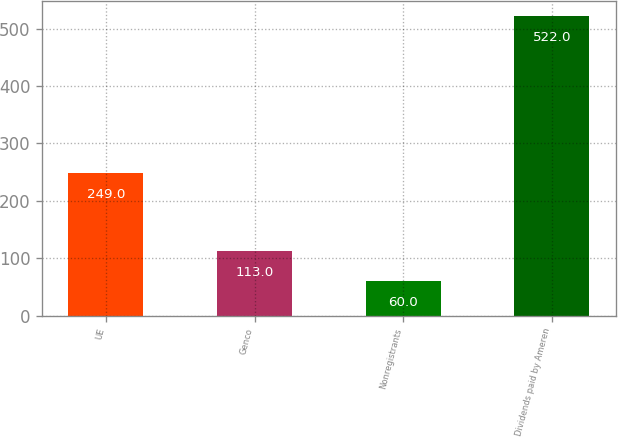Convert chart. <chart><loc_0><loc_0><loc_500><loc_500><bar_chart><fcel>UE<fcel>Genco<fcel>Nonregistrants<fcel>Dividends paid by Ameren<nl><fcel>249<fcel>113<fcel>60<fcel>522<nl></chart> 